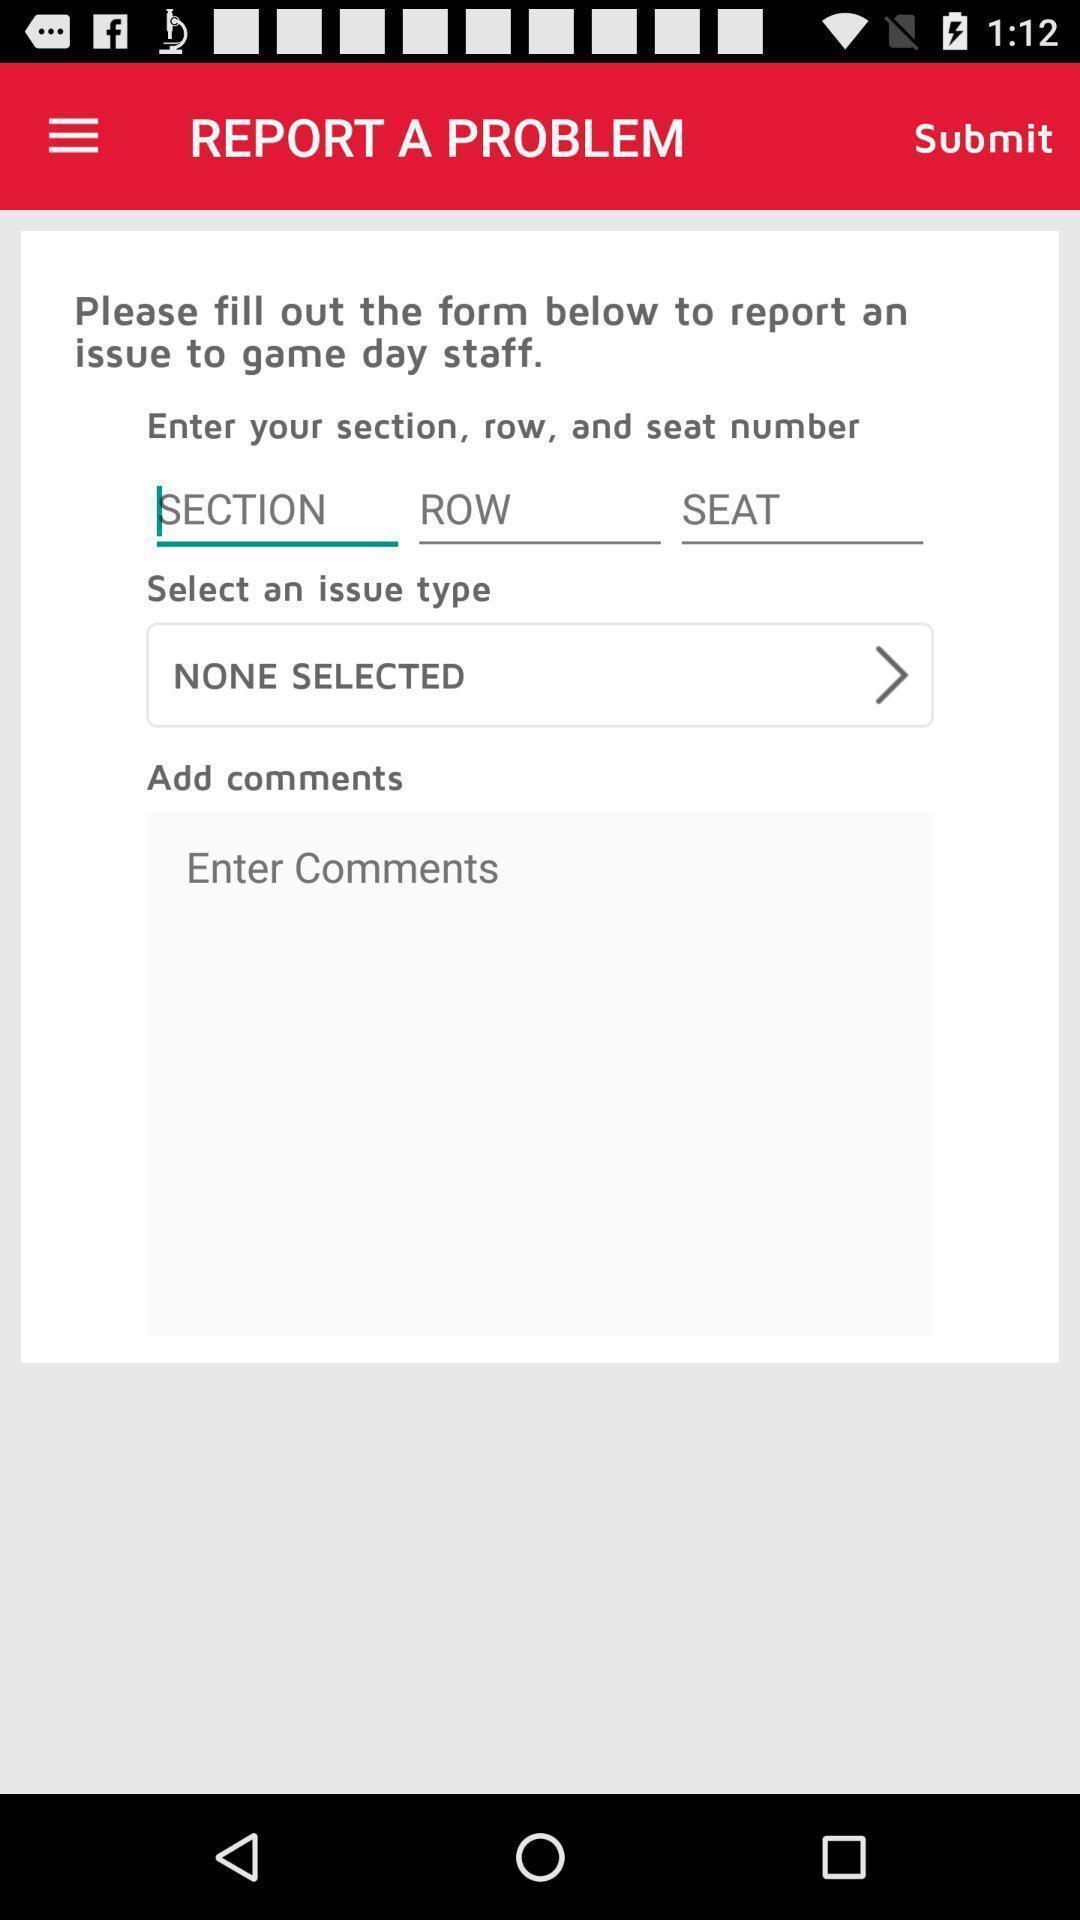Describe the key features of this screenshot. Screen asks to report a problem. 